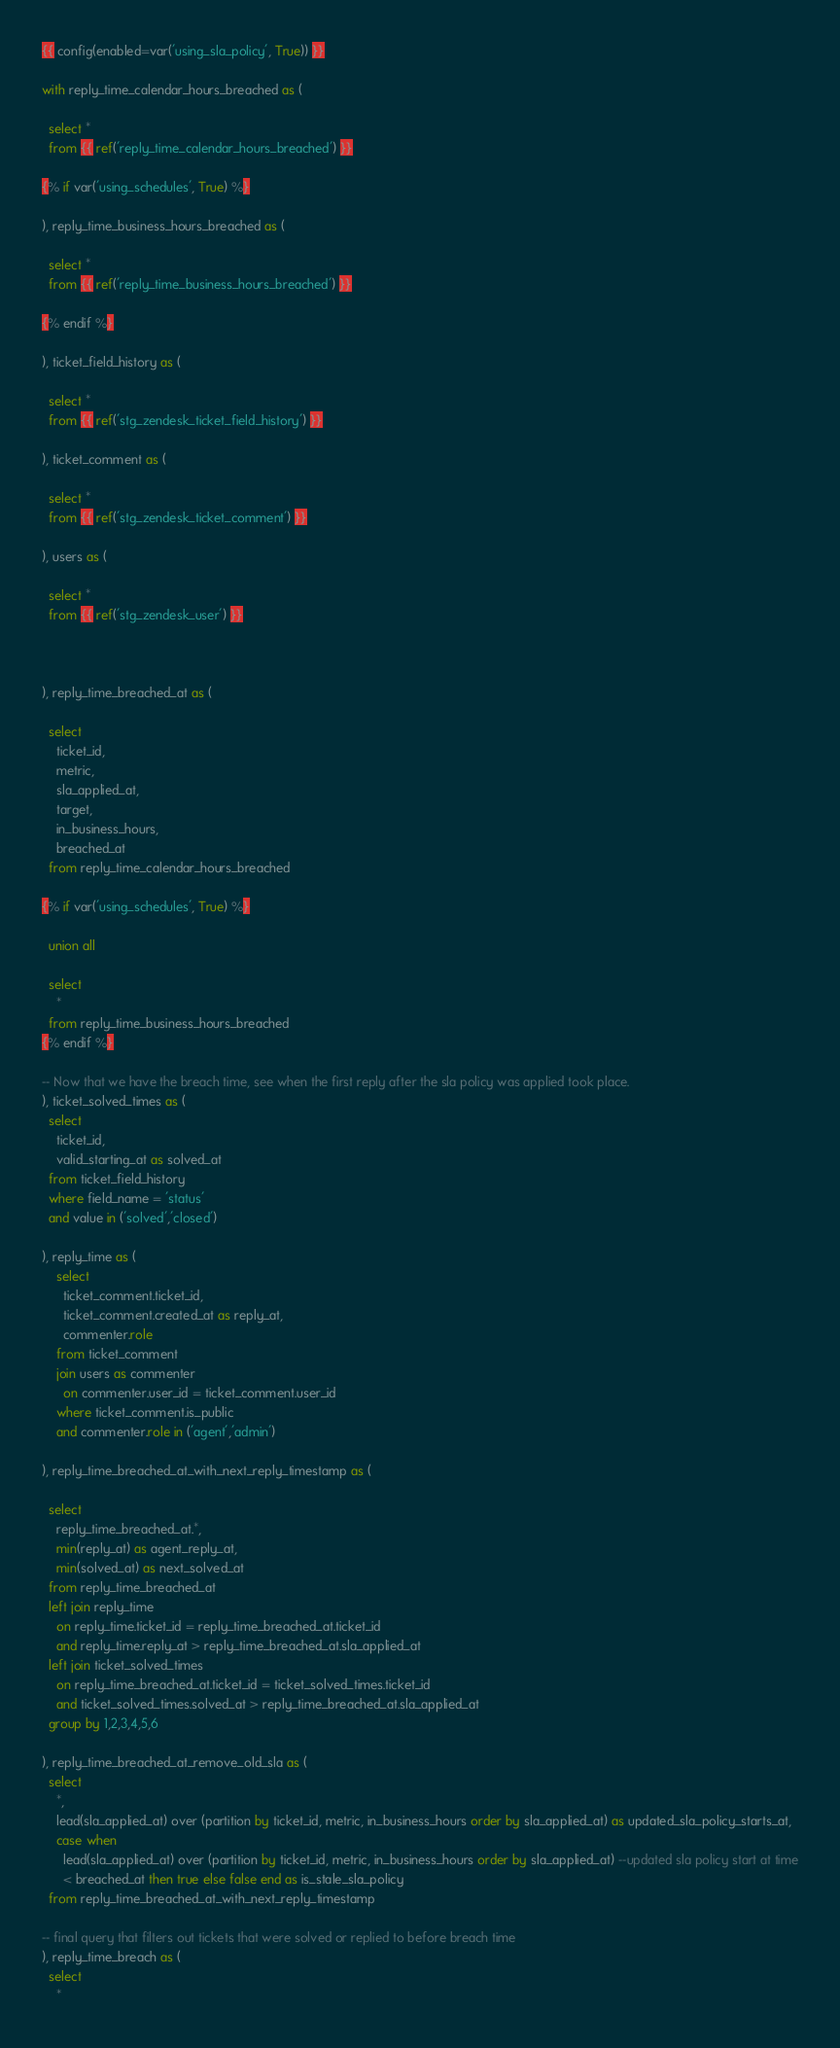Convert code to text. <code><loc_0><loc_0><loc_500><loc_500><_SQL_>{{ config(enabled=var('using_sla_policy', True)) }}

with reply_time_calendar_hours_breached as (
  
  select *
  from {{ ref('reply_time_calendar_hours_breached') }}

{% if var('using_schedules', True) %}

), reply_time_business_hours_breached as (
 
  select *
  from {{ ref('reply_time_business_hours_breached') }}

{% endif %}

), ticket_field_history as (
 
  select *
  from {{ ref('stg_zendesk_ticket_field_history') }}

), ticket_comment as (
 
  select *
  from {{ ref('stg_zendesk_ticket_comment') }}

), users as (
 
  select *
  from {{ ref('stg_zendesk_user') }}



), reply_time_breached_at as (

  select 
    ticket_id,
    metric,
    sla_applied_at,
    target,
    in_business_hours,
    breached_at
  from reply_time_calendar_hours_breached

{% if var('using_schedules', True) %}

  union all

  select 
    *
  from reply_time_business_hours_breached
{% endif %}

-- Now that we have the breach time, see when the first reply after the sla policy was applied took place.
), ticket_solved_times as (
  select
    ticket_id,
    valid_starting_at as solved_at
  from ticket_field_history
  where field_name = 'status'
  and value in ('solved','closed')

), reply_time as (
    select 
      ticket_comment.ticket_id,
      ticket_comment.created_at as reply_at,
      commenter.role
    from ticket_comment
    join users as commenter
      on commenter.user_id = ticket_comment.user_id
    where ticket_comment.is_public
    and commenter.role in ('agent','admin')

), reply_time_breached_at_with_next_reply_timestamp as (

  select 
    reply_time_breached_at.*,
    min(reply_at) as agent_reply_at,
    min(solved_at) as next_solved_at
  from reply_time_breached_at
  left join reply_time
    on reply_time.ticket_id = reply_time_breached_at.ticket_id
    and reply_time.reply_at > reply_time_breached_at.sla_applied_at
  left join ticket_solved_times
    on reply_time_breached_at.ticket_id = ticket_solved_times.ticket_id
    and ticket_solved_times.solved_at > reply_time_breached_at.sla_applied_at
  group by 1,2,3,4,5,6

), reply_time_breached_at_remove_old_sla as (
  select 
    *,
    lead(sla_applied_at) over (partition by ticket_id, metric, in_business_hours order by sla_applied_at) as updated_sla_policy_starts_at,
    case when 
      lead(sla_applied_at) over (partition by ticket_id, metric, in_business_hours order by sla_applied_at) --updated sla policy start at time
      < breached_at then true else false end as is_stale_sla_policy
  from reply_time_breached_at_with_next_reply_timestamp
  
-- final query that filters out tickets that were solved or replied to before breach time
), reply_time_breach as (
  select 
    * </code> 